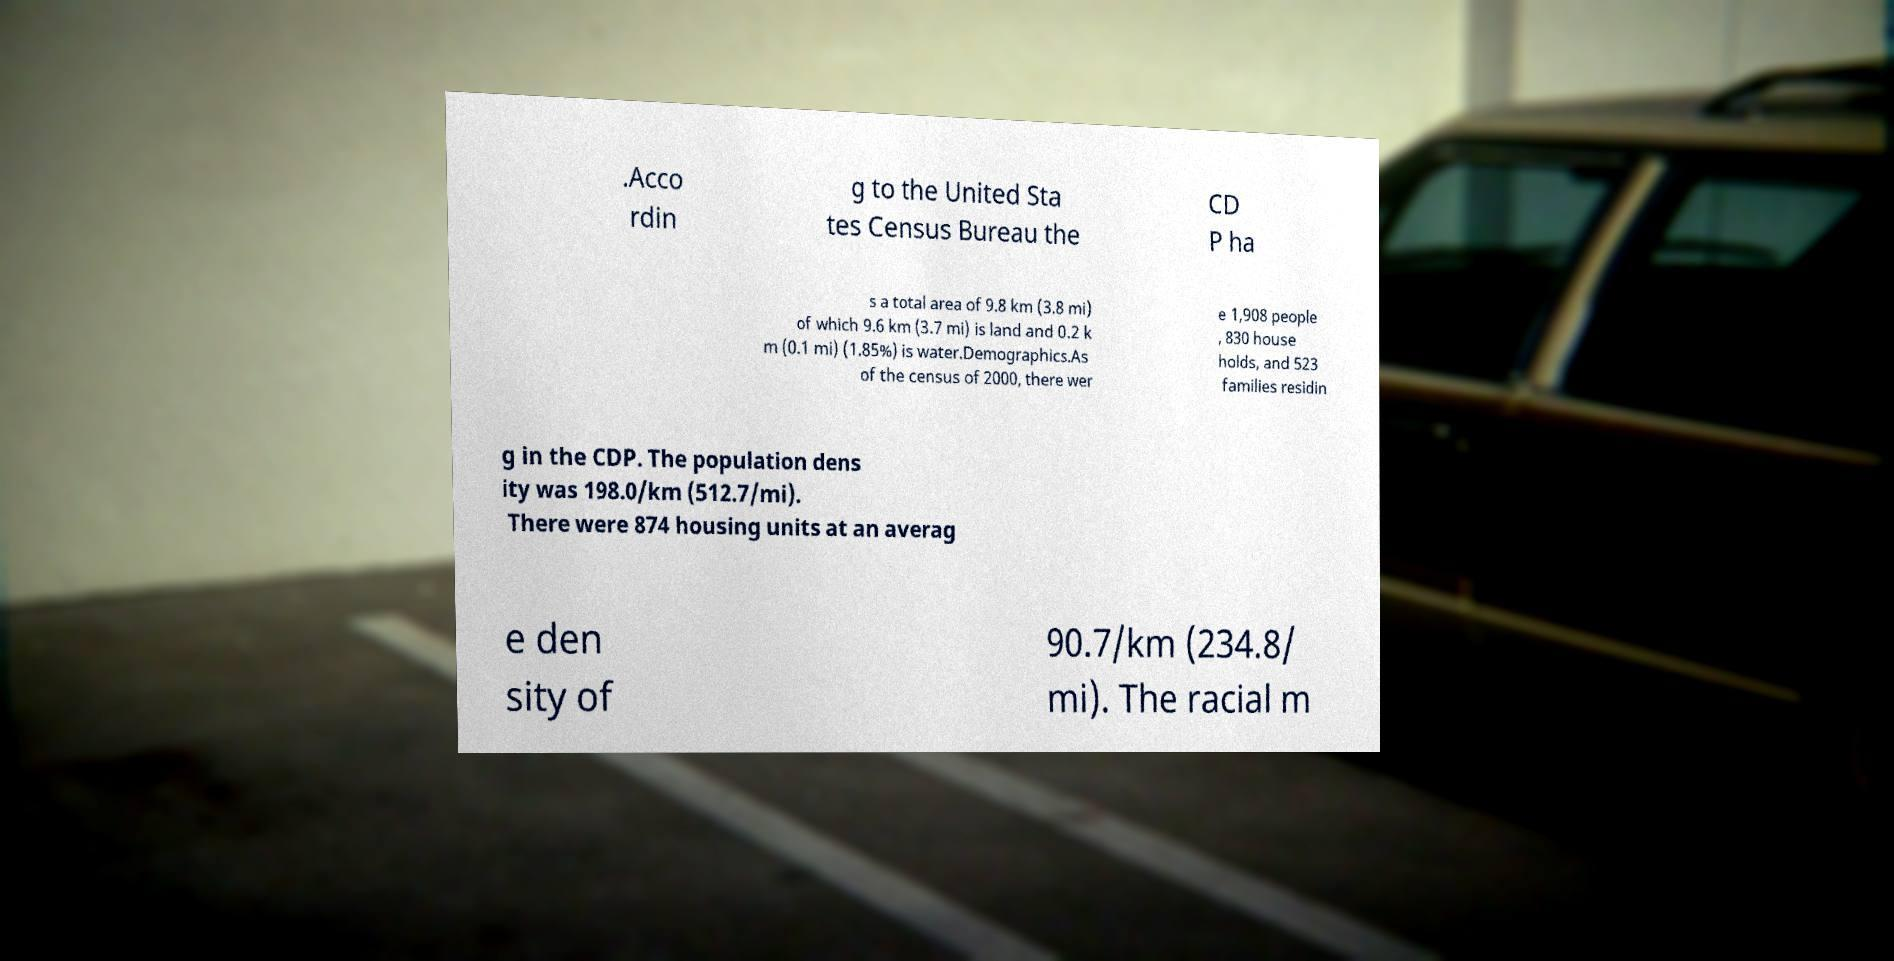Can you read and provide the text displayed in the image?This photo seems to have some interesting text. Can you extract and type it out for me? .Acco rdin g to the United Sta tes Census Bureau the CD P ha s a total area of 9.8 km (3.8 mi) of which 9.6 km (3.7 mi) is land and 0.2 k m (0.1 mi) (1.85%) is water.Demographics.As of the census of 2000, there wer e 1,908 people , 830 house holds, and 523 families residin g in the CDP. The population dens ity was 198.0/km (512.7/mi). There were 874 housing units at an averag e den sity of 90.7/km (234.8/ mi). The racial m 